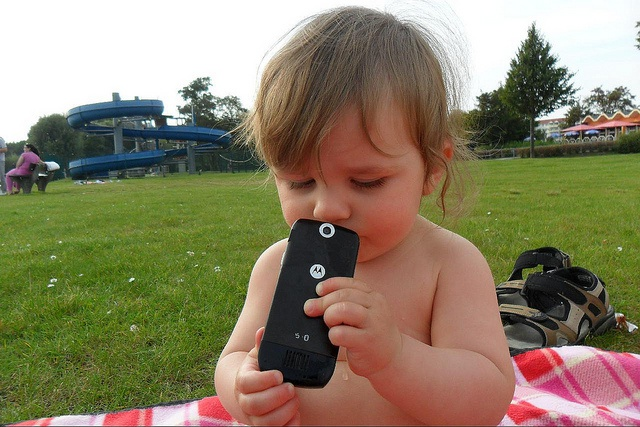Describe the objects in this image and their specific colors. I can see people in white, brown, black, and tan tones, cell phone in white, black, gray, darkgray, and lightgray tones, bench in white, black, gray, and darkgreen tones, people in white, gray, violet, purple, and black tones, and umbrella in white, darkgray, gray, and darkblue tones in this image. 